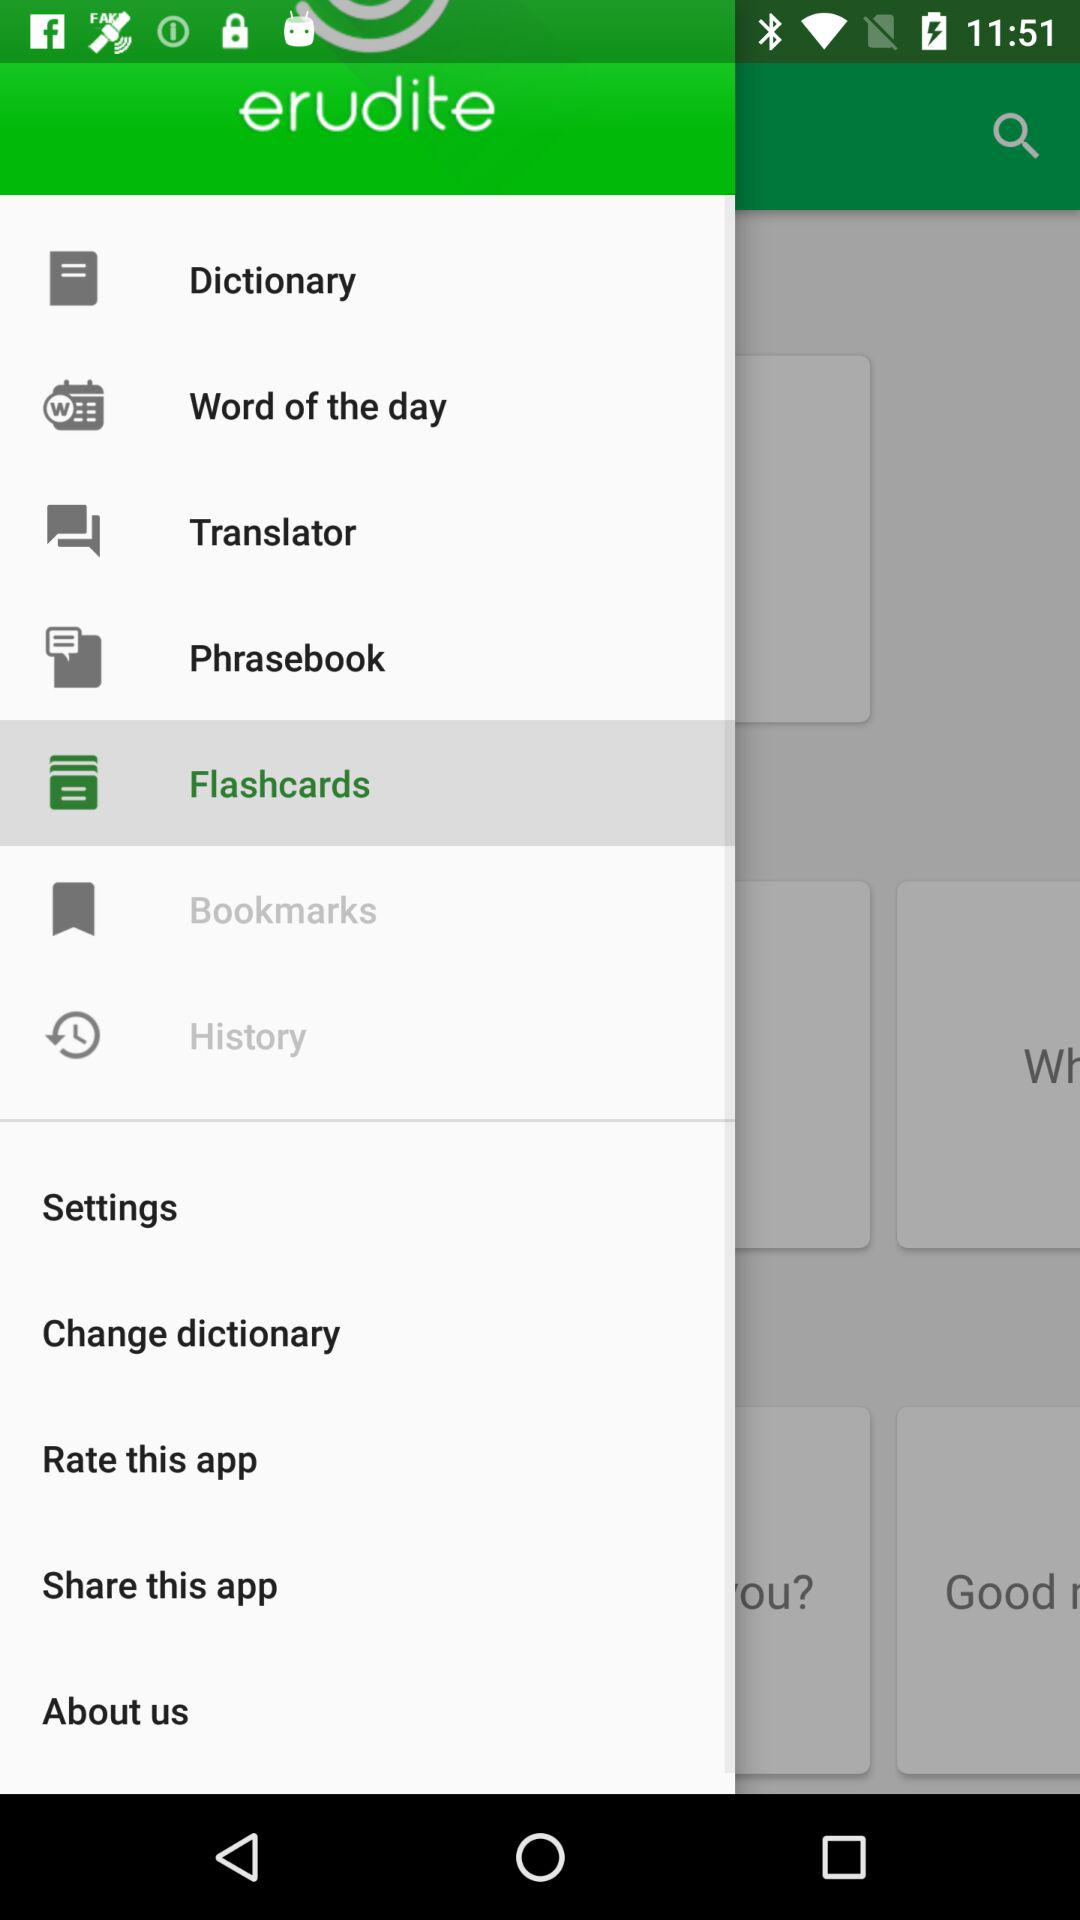How many items are there in the main menu?
Answer the question using a single word or phrase. 12 